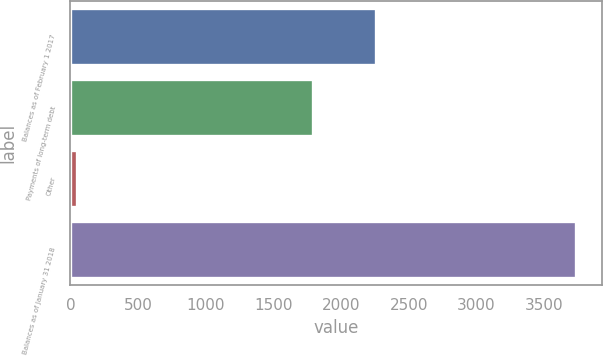Convert chart to OTSL. <chart><loc_0><loc_0><loc_500><loc_500><bar_chart><fcel>Balances as of February 1 2017<fcel>Payments of long-term debt<fcel>Other<fcel>Balances as of January 31 2018<nl><fcel>2256<fcel>1789<fcel>47<fcel>3738<nl></chart> 